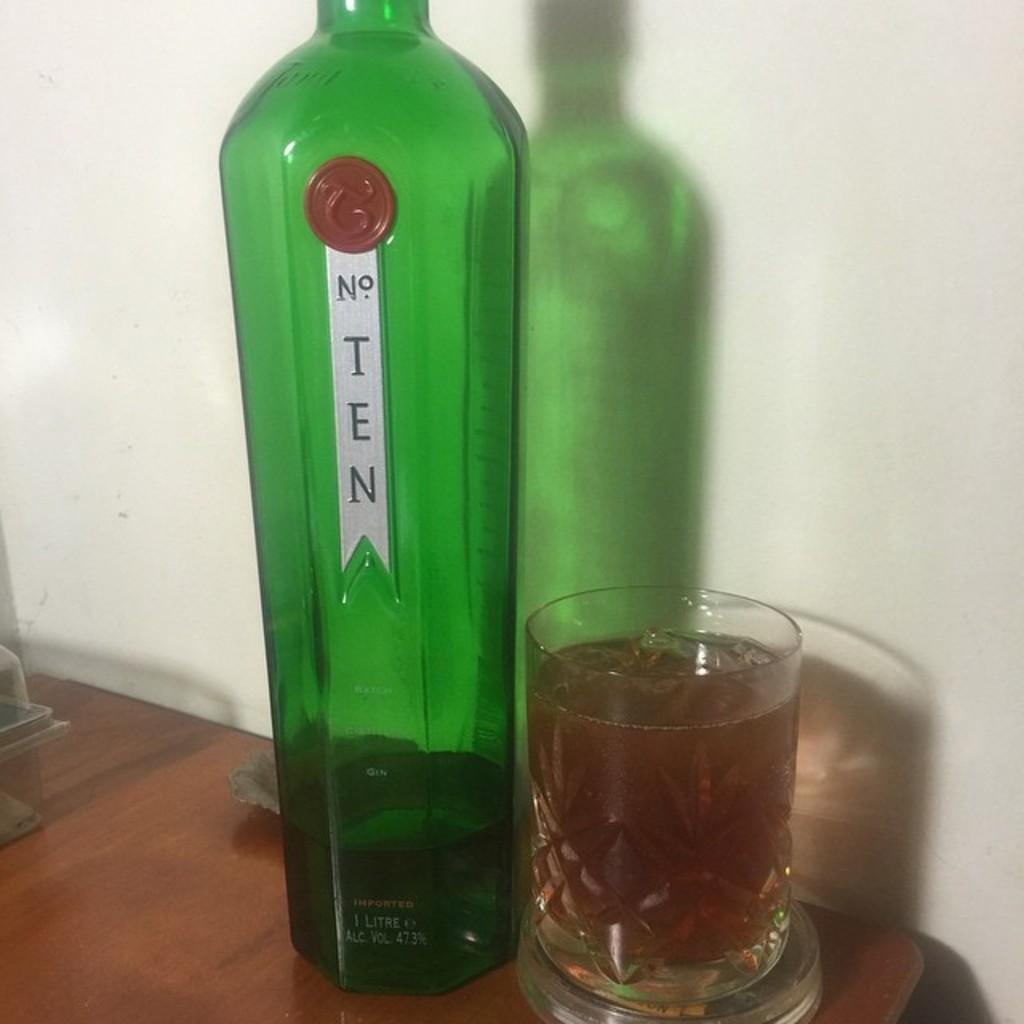In one or two sentences, can you explain what this image depicts? In this image I can see a bottle and glass on the table. 